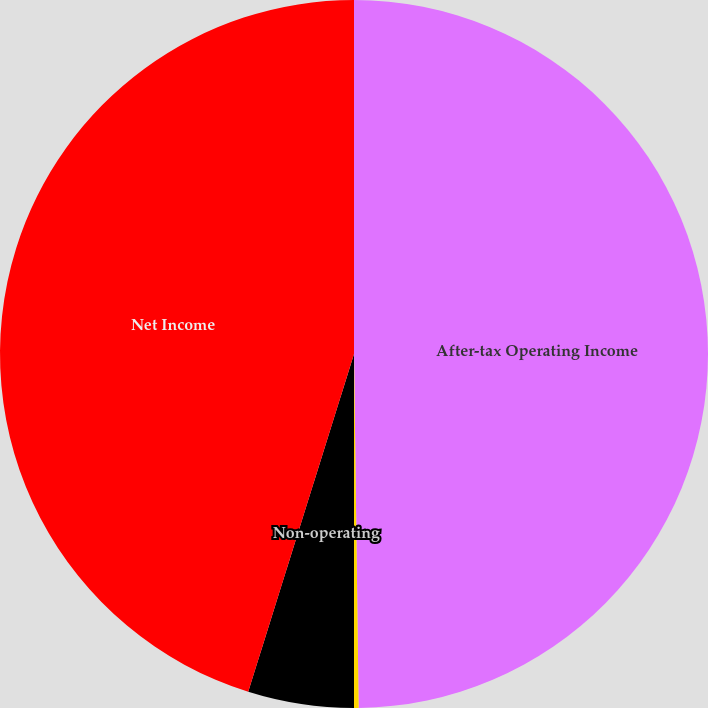Convert chart to OTSL. <chart><loc_0><loc_0><loc_500><loc_500><pie_chart><fcel>After-tax Operating Income<fcel>Net Realized Investment Gain<fcel>Non-operating<fcel>Net Income<nl><fcel>49.79%<fcel>0.21%<fcel>4.83%<fcel>45.17%<nl></chart> 